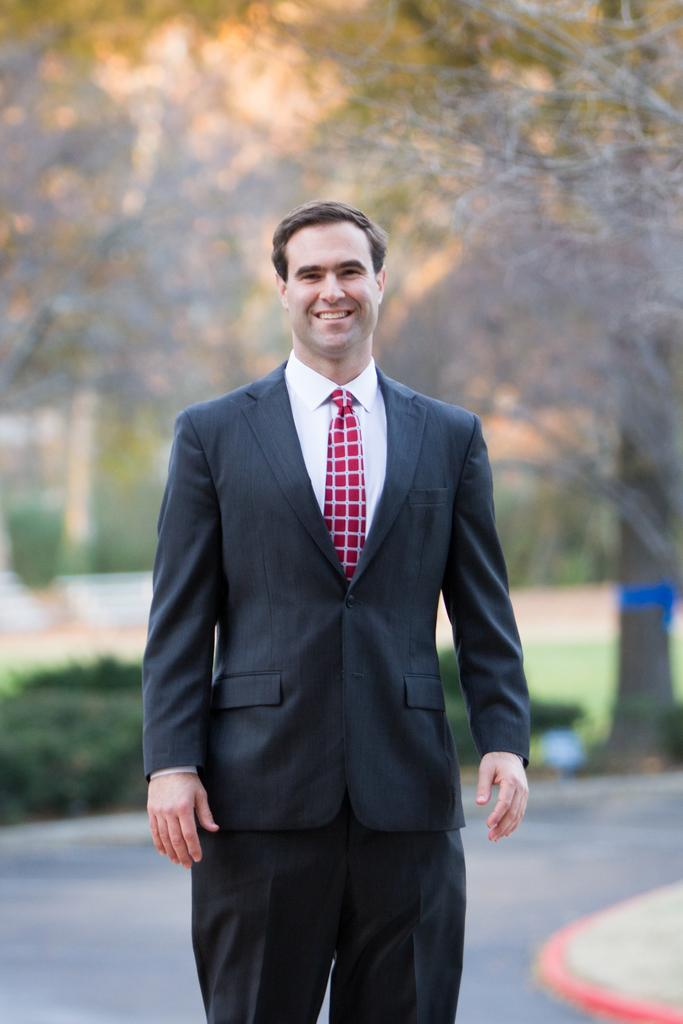What is the man in the image doing? The man is standing in the image. What is the man wearing? The man is wearing a black outfit and a red tie. What is the man's facial expression? The man is smiling. What can be seen in the background of the image? There is a road and a tree in the background of the image. Are there any cattle visible in the image? There are no cattle present in the image; it only features a man standing and the background elements mentioned. 